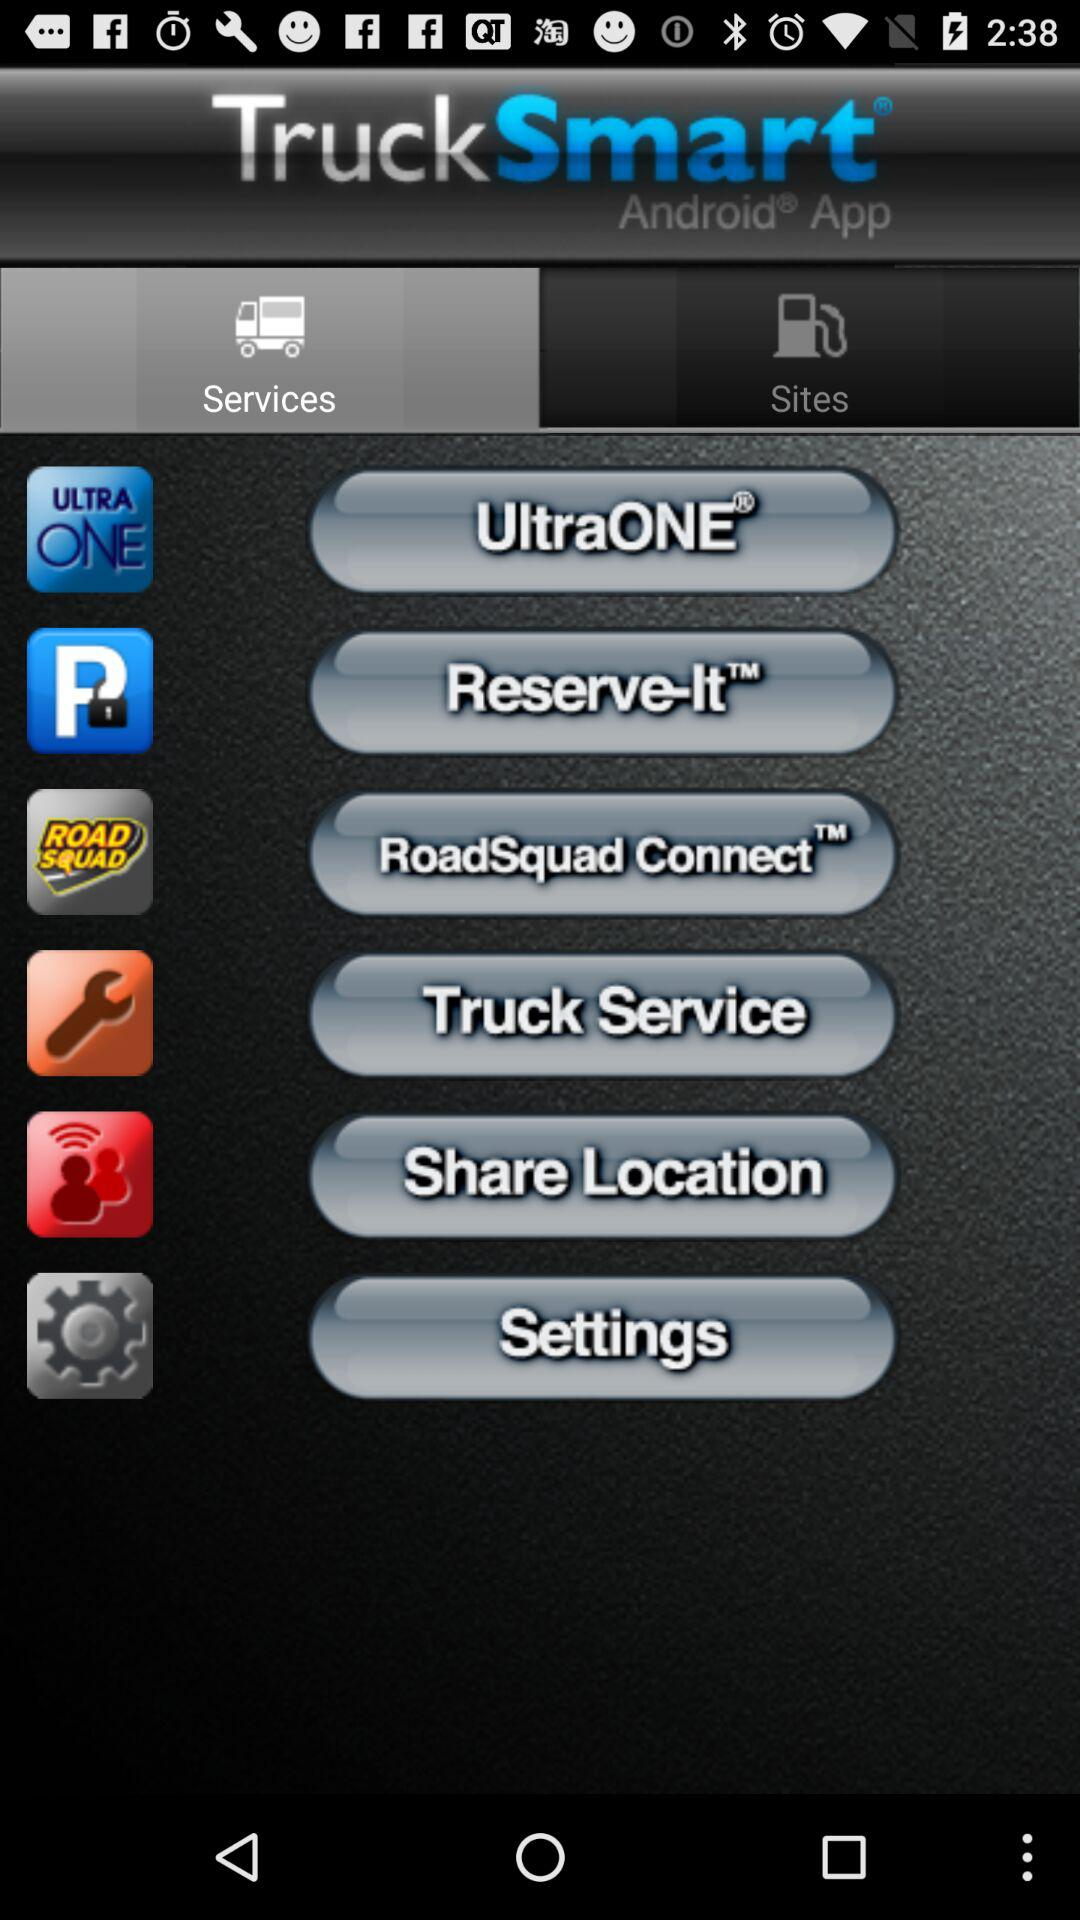Which tab is selected? The selected tab is "Services". 